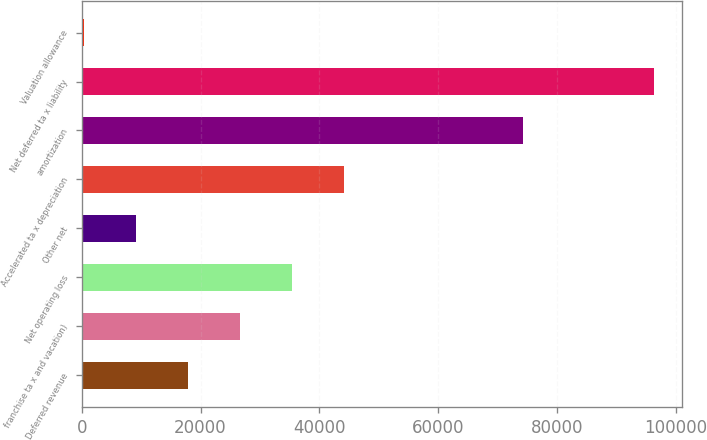Convert chart. <chart><loc_0><loc_0><loc_500><loc_500><bar_chart><fcel>Deferred revenue<fcel>franchise ta x and vacation)<fcel>Net operating loss<fcel>Other net<fcel>Accelerated ta x depreciation<fcel>amortization<fcel>Net deferred ta x liability<fcel>Valuation allowance<nl><fcel>17815.6<fcel>26570.4<fcel>35325.2<fcel>9060.8<fcel>44080<fcel>74341<fcel>96302.8<fcel>306<nl></chart> 